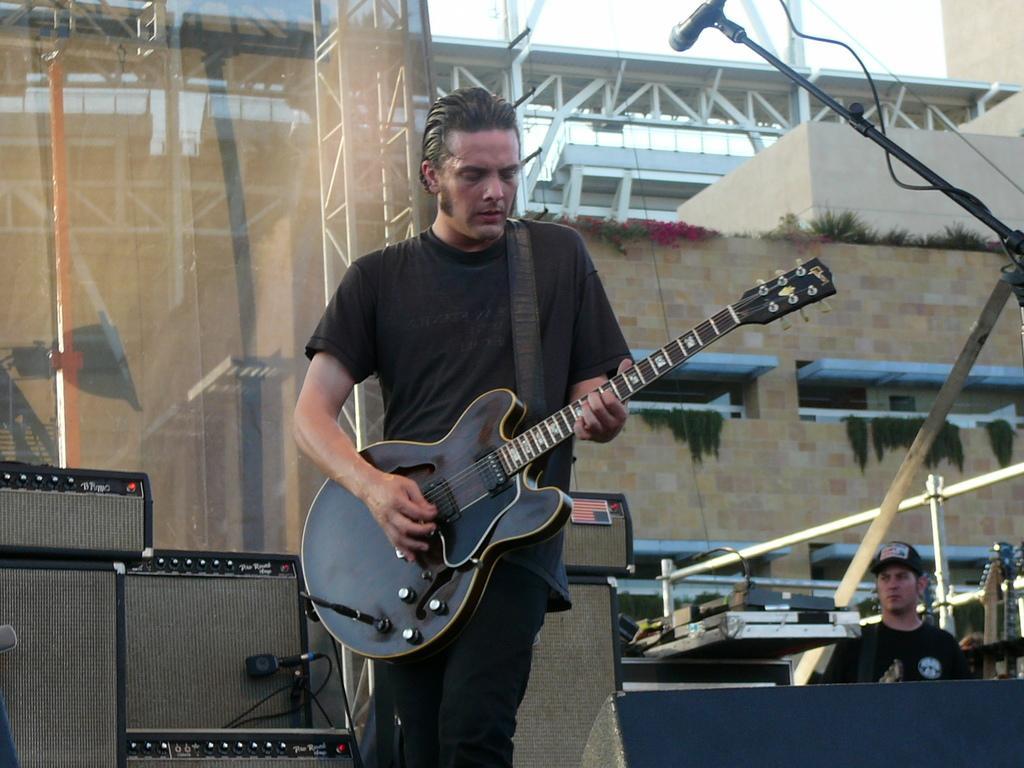How would you summarize this image in a sentence or two? In the image we can see there is a person who is standing and holding guitar in his hand and at the back there are speakers and behind there is person who is standing and wearing black colour cap and t shirt and behind there is a building. 